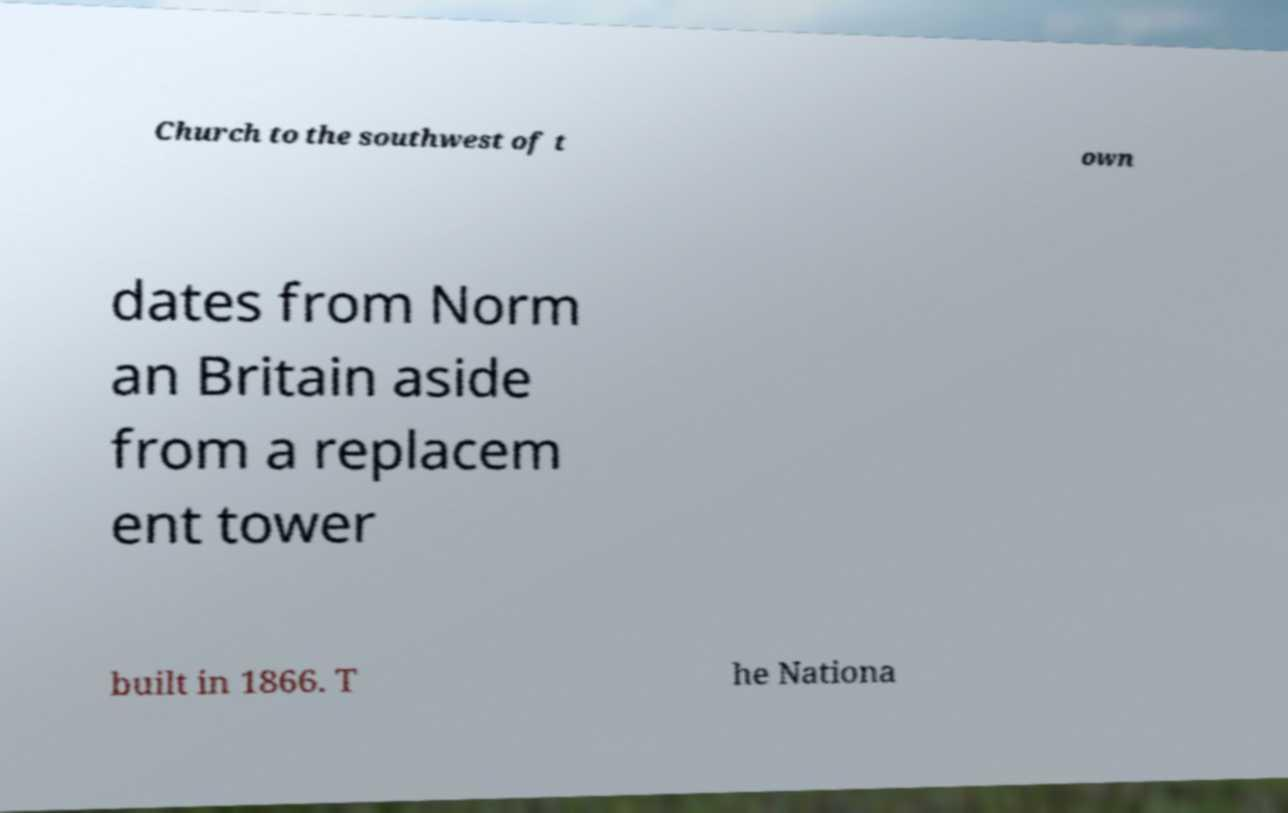Can you read and provide the text displayed in the image?This photo seems to have some interesting text. Can you extract and type it out for me? Church to the southwest of t own dates from Norm an Britain aside from a replacem ent tower built in 1866. T he Nationa 